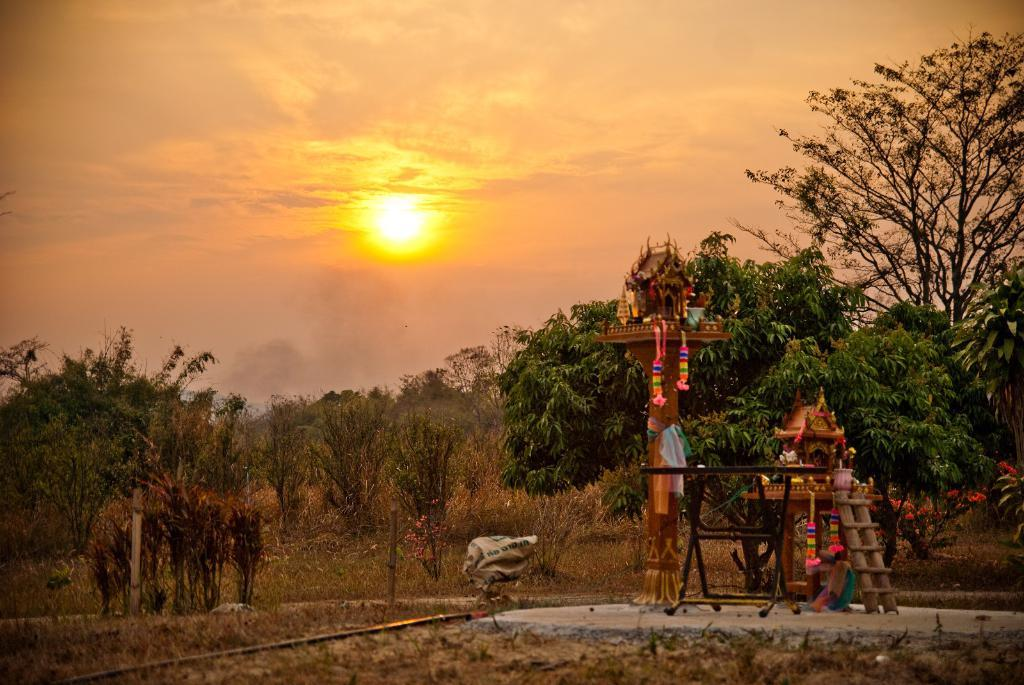What type of vegetation can be seen in the image? There are trees and plants in the image. What structure is present in the image? There is a pillar in the image. What object can be used for climbing in the image? There is a ladder in the image. What is visible in the background of the image? The sky is visible in the image. Can you tell me where the store is located in the image? There is no store present in the image. What type of weather condition is depicted in the image? The provided facts do not mention any weather conditions, so we cannot determine if there is fog or any other weather condition in the image. 